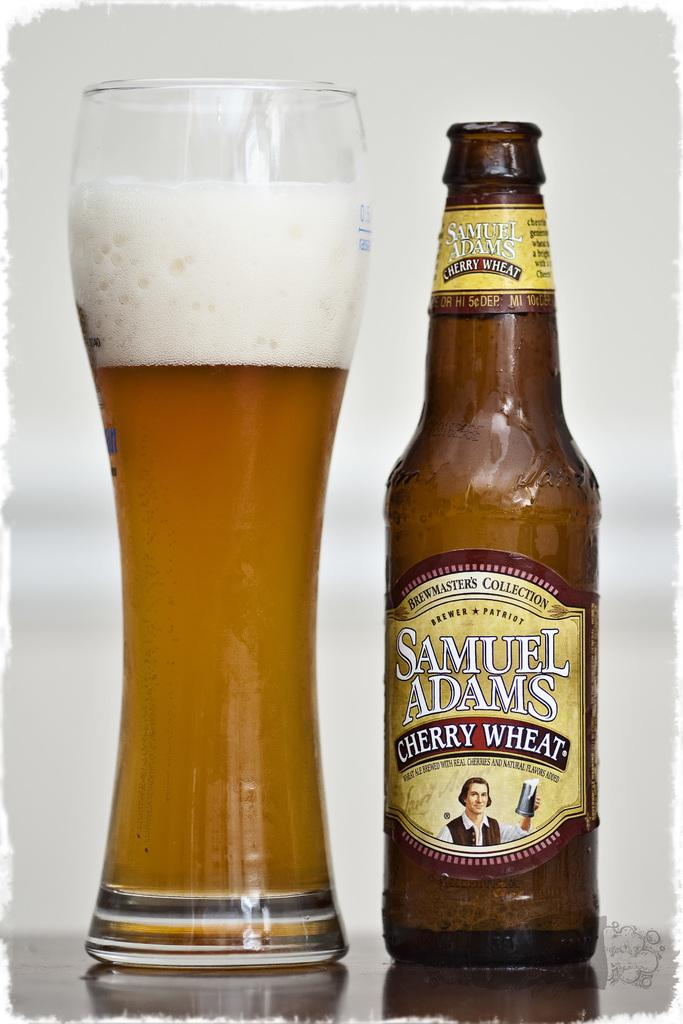Provide a one-sentence caption for the provided image. A glass bottle of Samuel Adams Cherry Wheat Beer. 